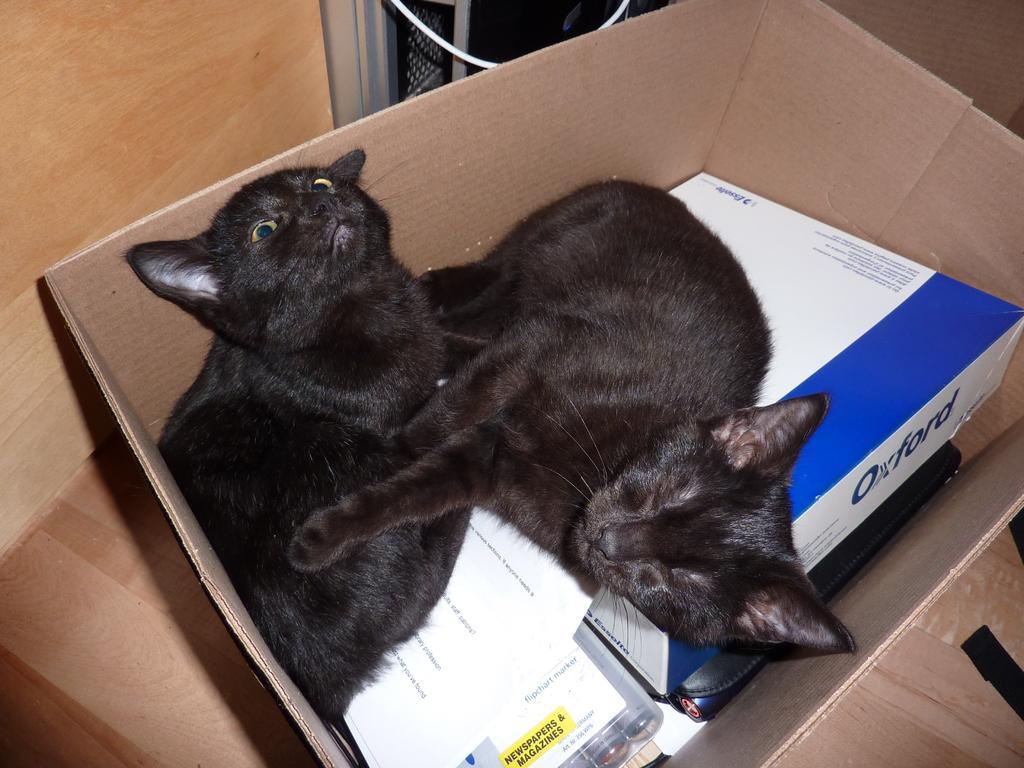How would you summarize this image in a sentence or two? In this image in the center there is one box, in that box there are some cats and also there are some papers and some objects. In the background there is wall and some objects. 